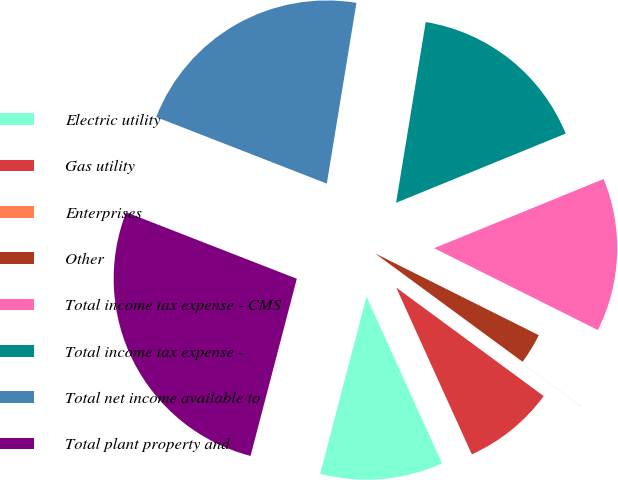Convert chart to OTSL. <chart><loc_0><loc_0><loc_500><loc_500><pie_chart><fcel>Electric utility<fcel>Gas utility<fcel>Enterprises<fcel>Other<fcel>Total income tax expense - CMS<fcel>Total income tax expense -<fcel>Total net income available to<fcel>Total plant property and<nl><fcel>10.84%<fcel>8.13%<fcel>0.01%<fcel>2.71%<fcel>13.54%<fcel>16.25%<fcel>21.67%<fcel>26.85%<nl></chart> 